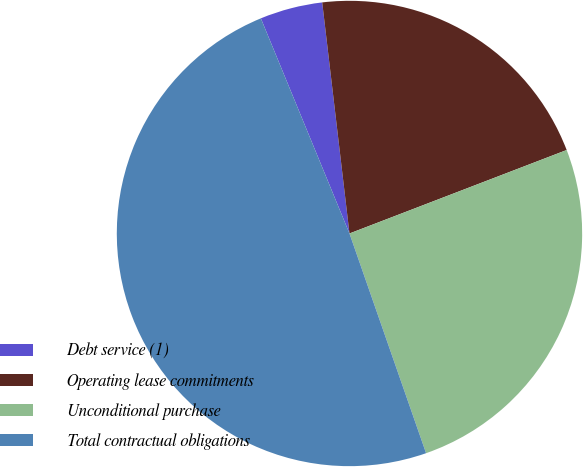Convert chart to OTSL. <chart><loc_0><loc_0><loc_500><loc_500><pie_chart><fcel>Debt service (1)<fcel>Operating lease commitments<fcel>Unconditional purchase<fcel>Total contractual obligations<nl><fcel>4.35%<fcel>21.03%<fcel>25.5%<fcel>49.12%<nl></chart> 